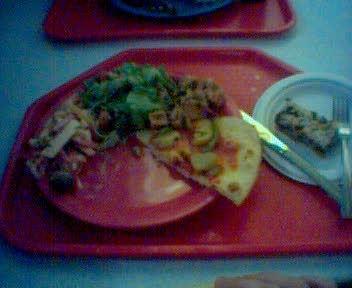How many trays are shown?
Give a very brief answer. 2. How many pizzas are there?
Give a very brief answer. 1. How many people are wearing a birthday hat?
Give a very brief answer. 0. 